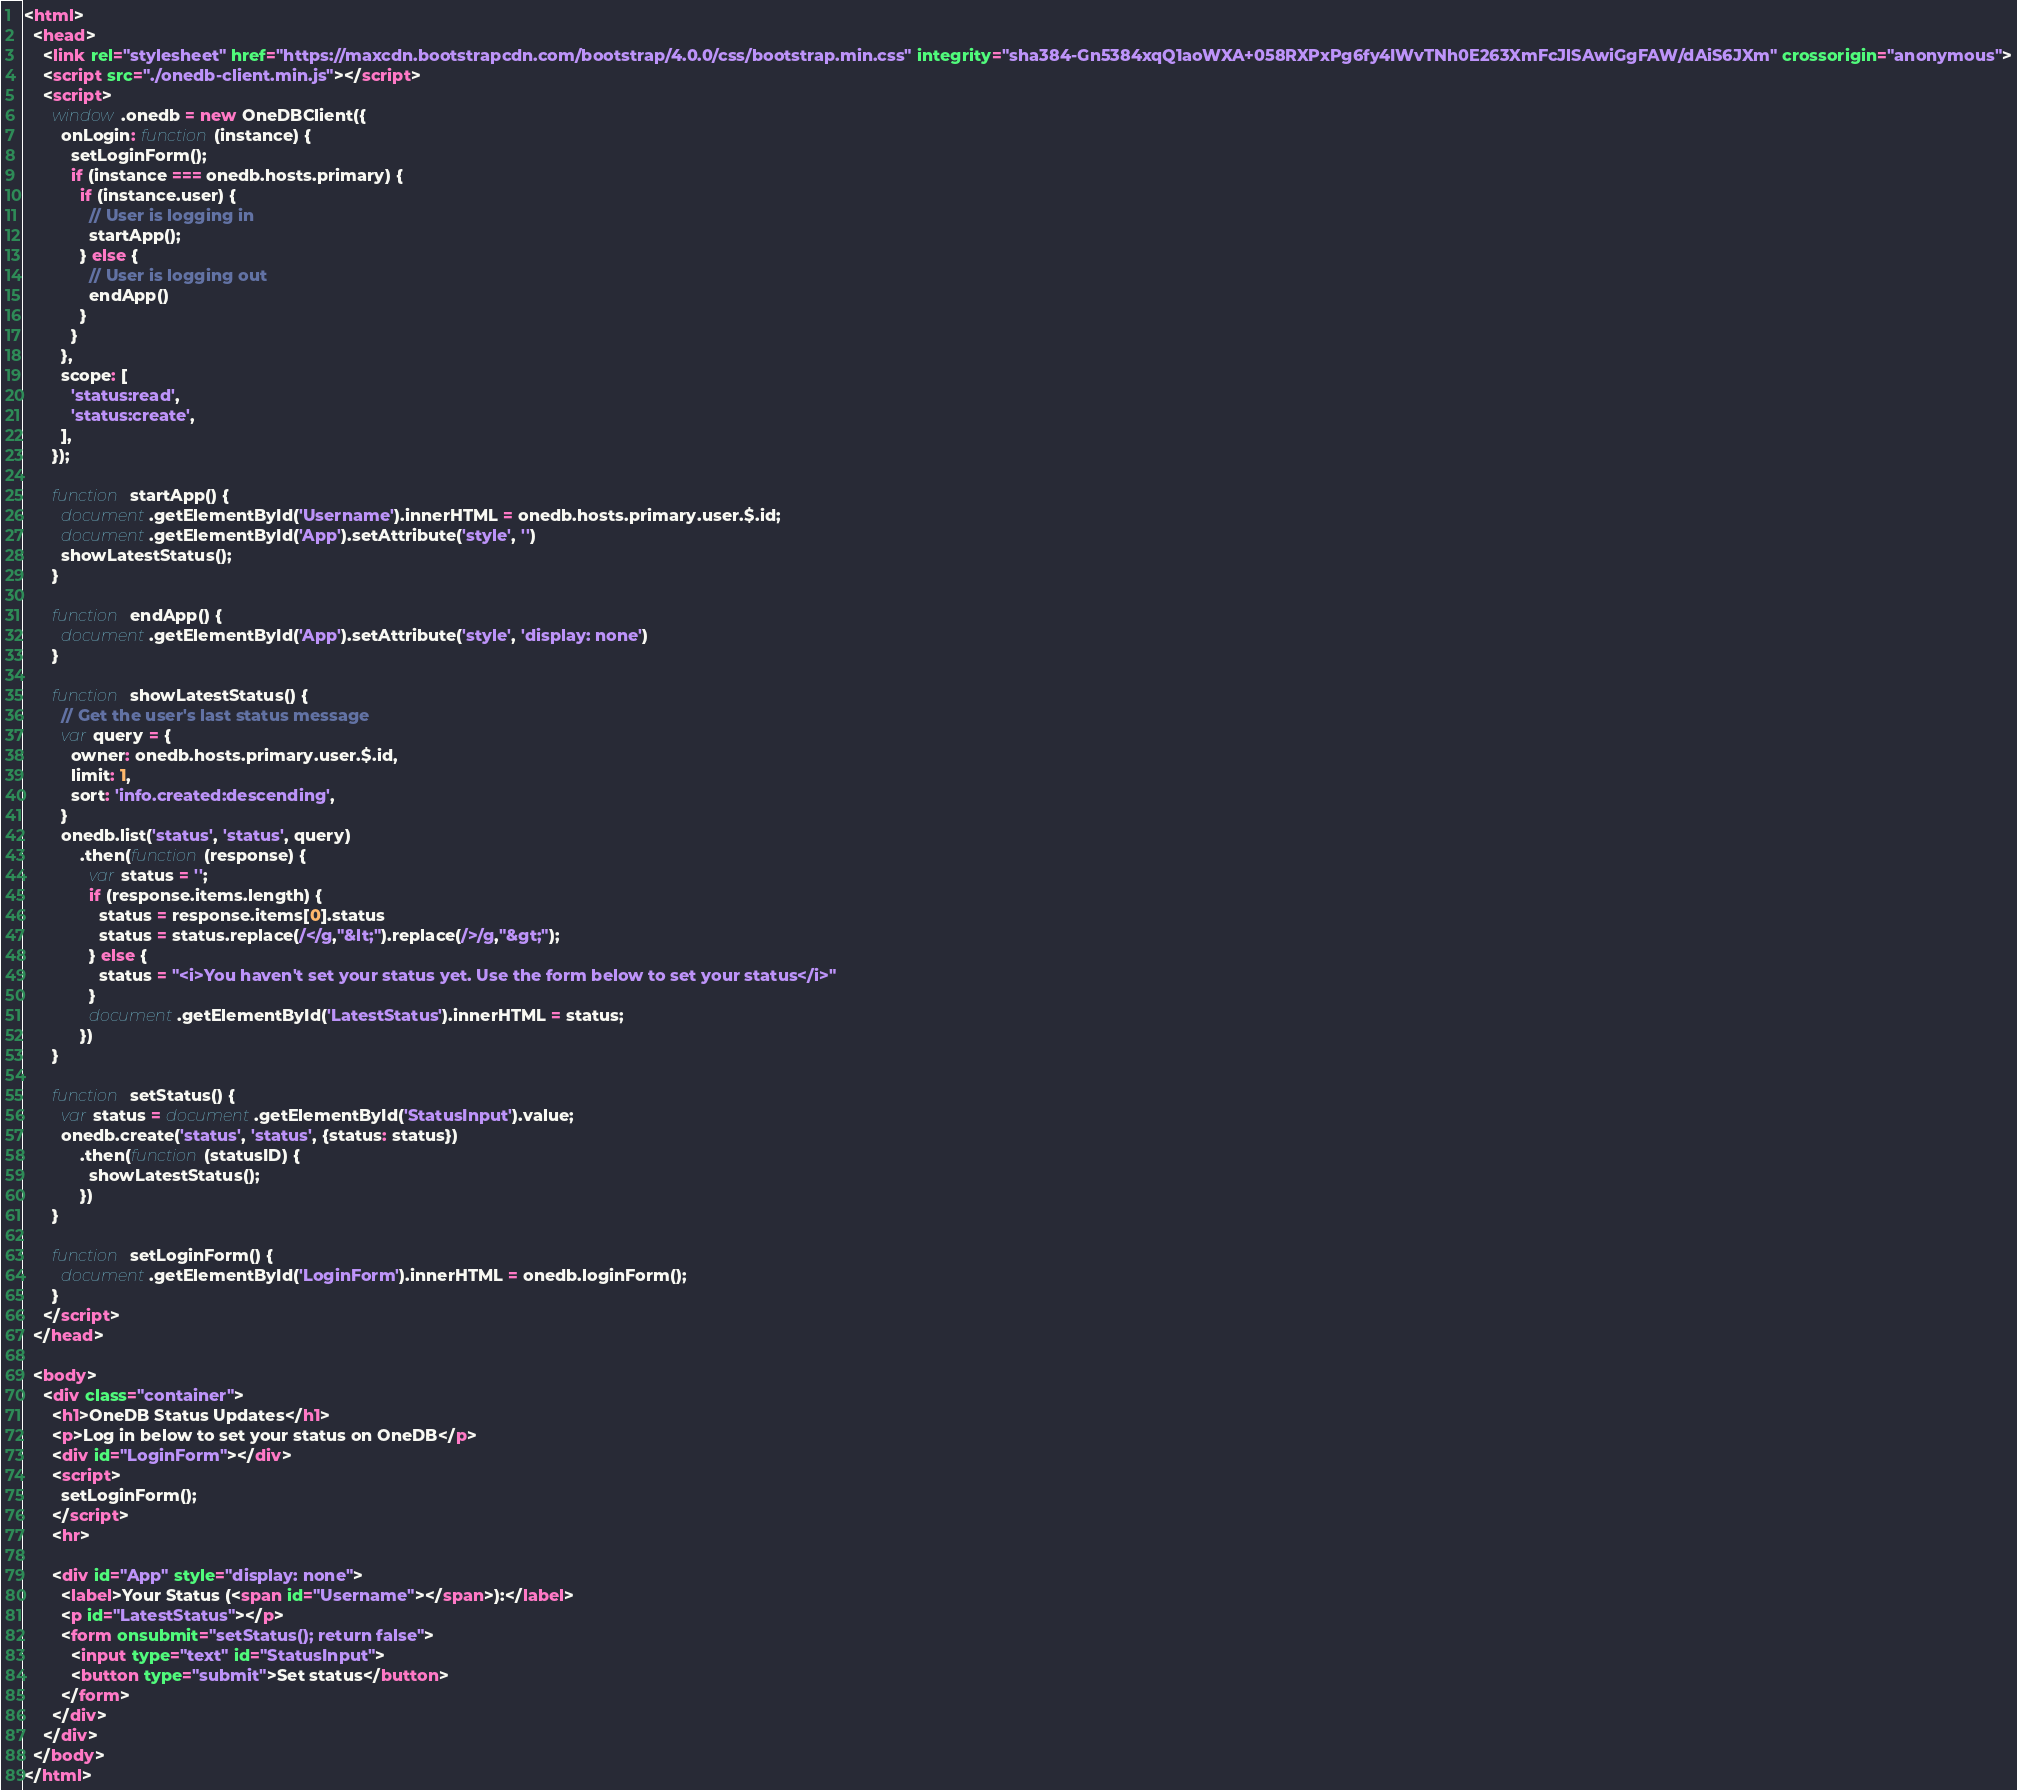Convert code to text. <code><loc_0><loc_0><loc_500><loc_500><_HTML_><html>
  <head>
    <link rel="stylesheet" href="https://maxcdn.bootstrapcdn.com/bootstrap/4.0.0/css/bootstrap.min.css" integrity="sha384-Gn5384xqQ1aoWXA+058RXPxPg6fy4IWvTNh0E263XmFcJlSAwiGgFAW/dAiS6JXm" crossorigin="anonymous">
    <script src="./onedb-client.min.js"></script>
    <script>
	  window.onedb = new OneDBClient({
		onLogin: function(instance) {
          setLoginForm();
          if (instance === onedb.hosts.primary) {
            if (instance.user) {
              // User is logging in
              startApp();
            } else {
              // User is logging out
              endApp()
            }
          }
		},
		scope: [
          'status:read',
          'status:create',
        ],
	  });

      function startApp() {
        document.getElementById('Username').innerHTML = onedb.hosts.primary.user.$.id;
        document.getElementById('App').setAttribute('style', '')
        showLatestStatus();
      }

      function endApp() {
        document.getElementById('App').setAttribute('style', 'display: none')
      }

      function showLatestStatus() {
        // Get the user's last status message
        var query = {
          owner: onedb.hosts.primary.user.$.id,
          limit: 1,
          sort: 'info.created:descending',
        }
        onedb.list('status', 'status', query)
            .then(function(response) {
              var status = '';
              if (response.items.length) {
                status = response.items[0].status
                status = status.replace(/</g,"&lt;").replace(/>/g,"&gt;");
              } else {
                status = "<i>You haven't set your status yet. Use the form below to set your status</i>"
              }
              document.getElementById('LatestStatus').innerHTML = status;
            })
      }

      function setStatus() {
        var status = document.getElementById('StatusInput').value;
        onedb.create('status', 'status', {status: status})
            .then(function(statusID) {
              showLatestStatus();
            })
      }

      function setLoginForm() {
        document.getElementById('LoginForm').innerHTML = onedb.loginForm();
      }
    </script>
  </head>

  <body>
    <div class="container">
      <h1>OneDB Status Updates</h1>
      <p>Log in below to set your status on OneDB</p>
      <div id="LoginForm"></div>
      <script>
        setLoginForm();
      </script>
      <hr>

      <div id="App" style="display: none">
        <label>Your Status (<span id="Username"></span>):</label>
        <p id="LatestStatus"></p>
        <form onsubmit="setStatus(); return false">
          <input type="text" id="StatusInput">
          <button type="submit">Set status</button>
        </form>
      </div>
    </div>
  </body>
</html>
</code> 